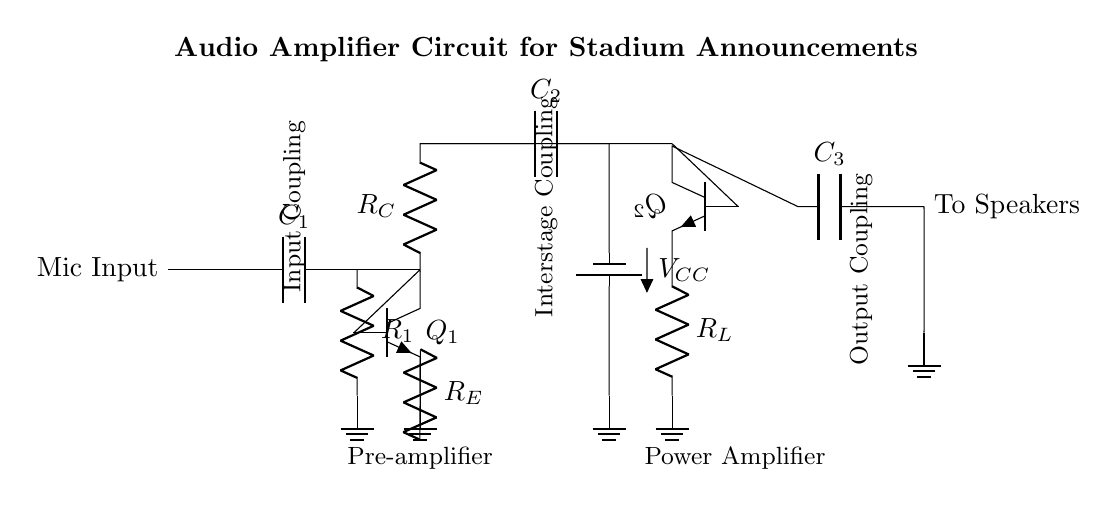What is the main function of this circuit? The main function is amplification of audio signals for announcements, which is evident from the presence of multiple amplifier stages in the circuit design.
Answer: Amplification What type of capacitors are present in the circuit? The circuit includes coupling capacitors, which can be identified by their labeling, such as C1, C2, and C3. They are used to block DC while allowing AC signals to pass through.
Answer: Coupling capacitors How many transistor stages are in the circuit? There are two transistor stages, as indicated by the presence of Q1 and Q2 in the circuit diagram, which perform the pre-amplification and power amplification functions respectively.
Answer: Two What component is used to limit the current flowing through the output speaker? The component used to limit current is R_L, as indicated in the circuit diagram, and it serves as the load resistor for the output stage of the amplifier.
Answer: R_L What does the voltage source V_CC power? V_CC powers the entire amplifier circuit, particularly the transistor stages, as indicated by the connection of the power supply to the collector of Q1 and the emitter of Q2.
Answer: The amplifier circuit What is the purpose of the coupling capacitors in this audio amplifier? The coupling capacitors (C1, C2, C3) allow the AC audio signals to pass between stages while blocking any DC voltage, preventing unwanted biasing within the amplifier stages.
Answer: Block DC, allow AC 